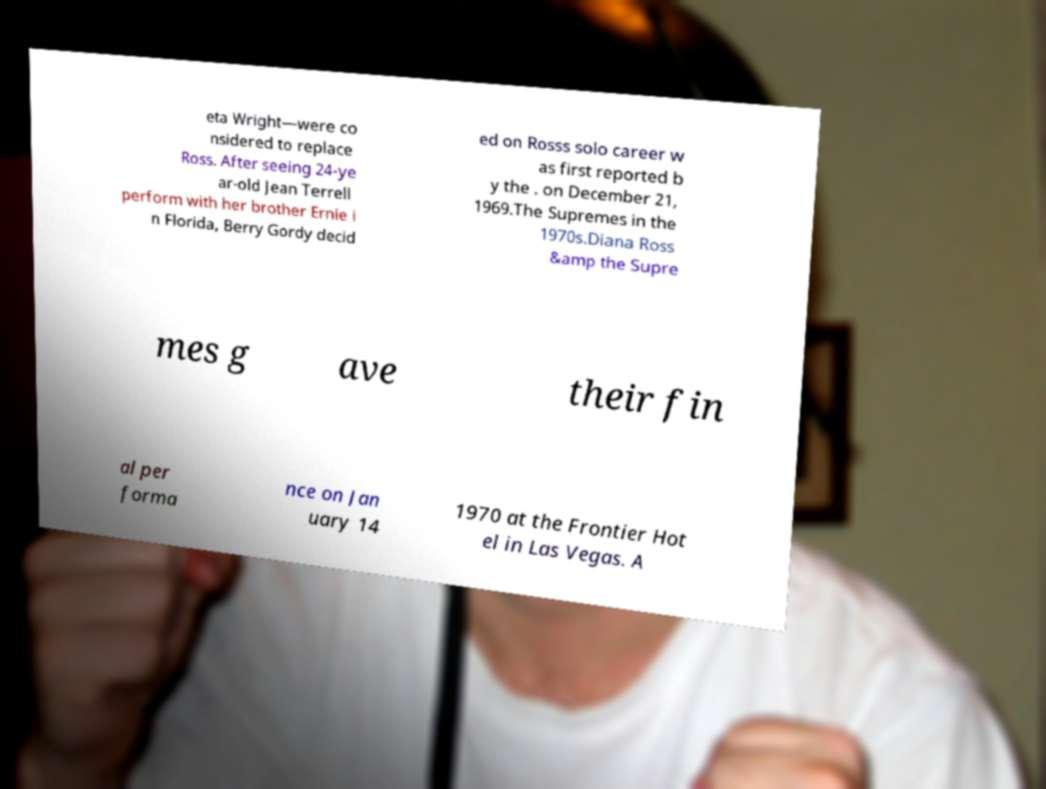Could you assist in decoding the text presented in this image and type it out clearly? eta Wright—were co nsidered to replace Ross. After seeing 24-ye ar-old Jean Terrell perform with her brother Ernie i n Florida, Berry Gordy decid ed on Rosss solo career w as first reported b y the . on December 21, 1969.The Supremes in the 1970s.Diana Ross &amp the Supre mes g ave their fin al per forma nce on Jan uary 14 1970 at the Frontier Hot el in Las Vegas. A 